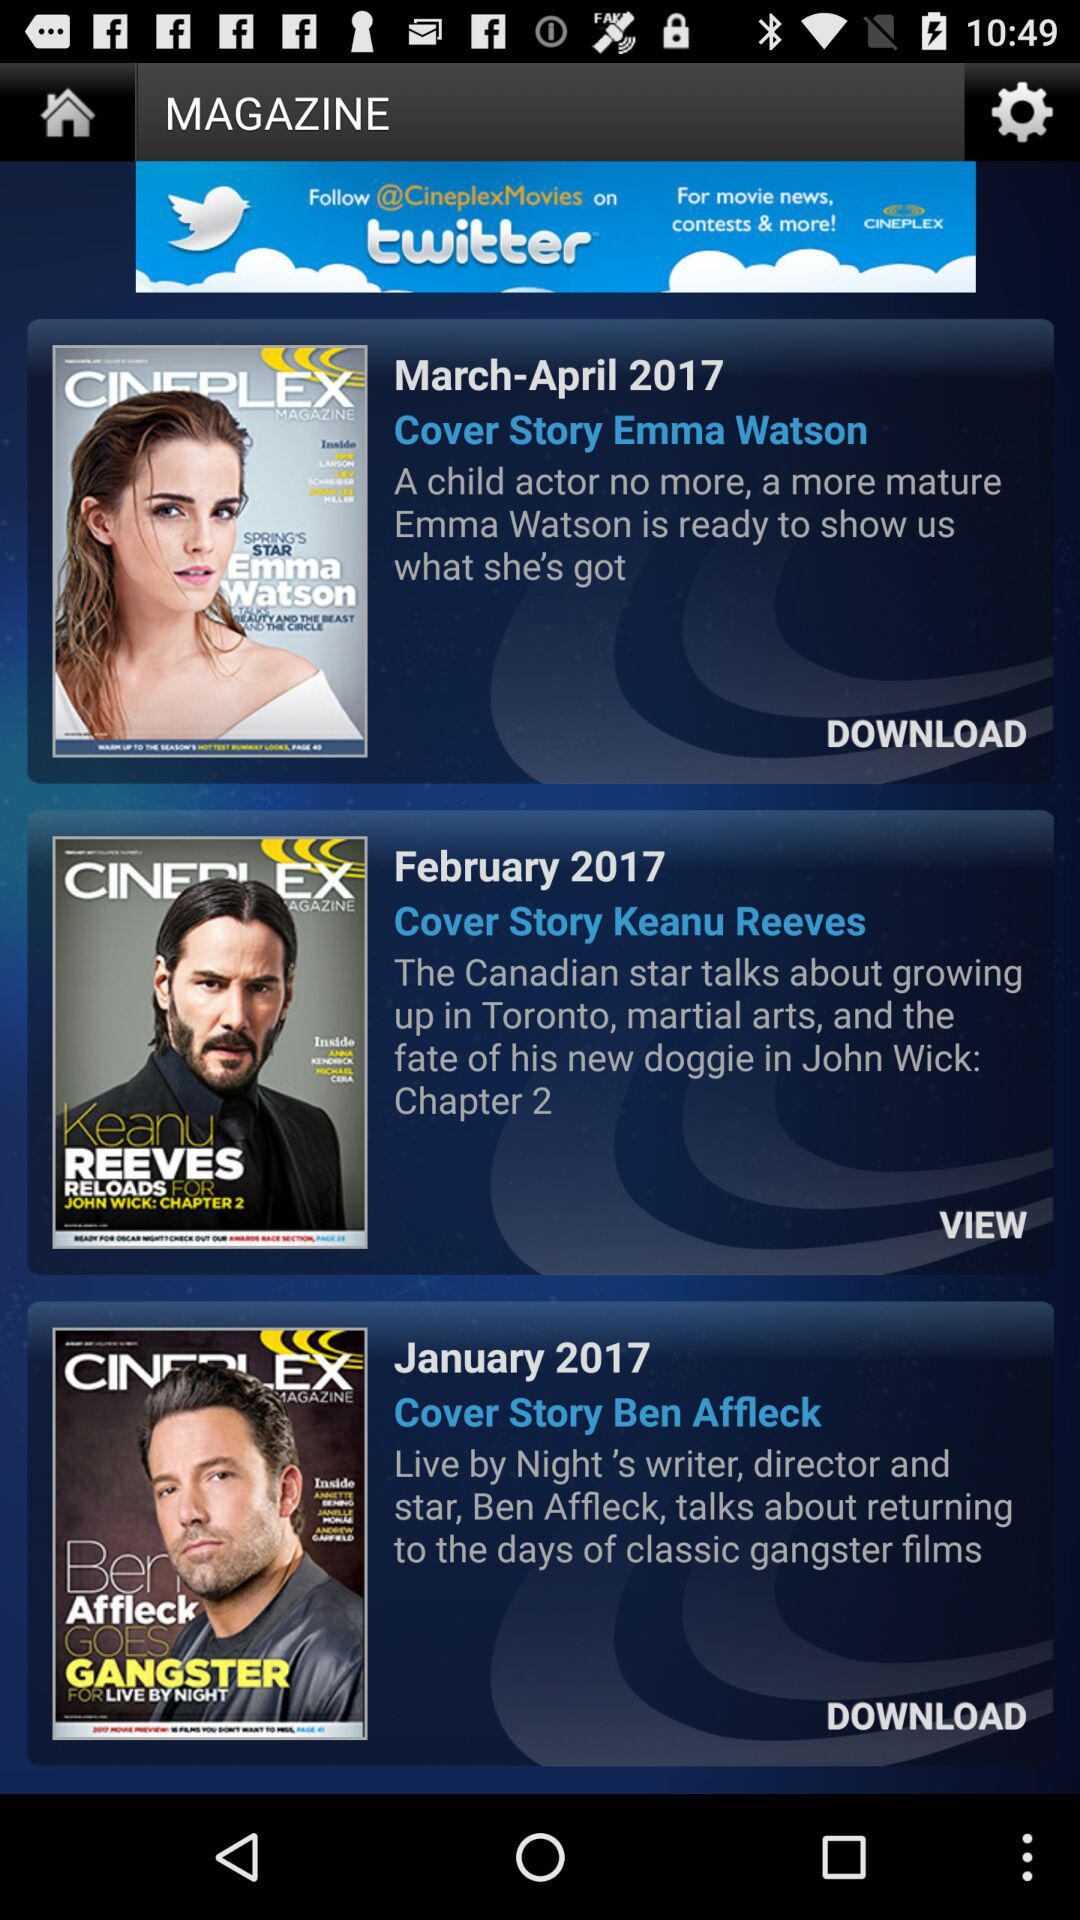How many magazine covers are there?
Answer the question using a single word or phrase. 3 